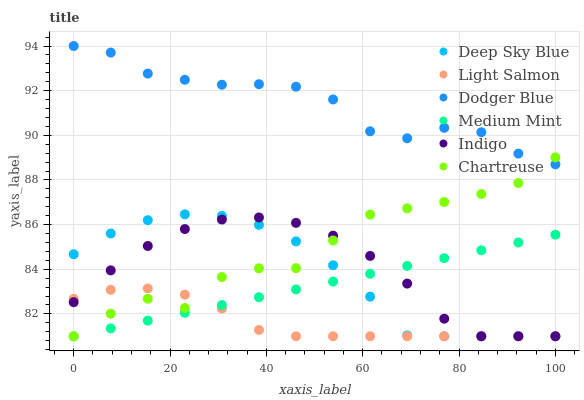Does Light Salmon have the minimum area under the curve?
Answer yes or no. Yes. Does Dodger Blue have the maximum area under the curve?
Answer yes or no. Yes. Does Indigo have the minimum area under the curve?
Answer yes or no. No. Does Indigo have the maximum area under the curve?
Answer yes or no. No. Is Medium Mint the smoothest?
Answer yes or no. Yes. Is Chartreuse the roughest?
Answer yes or no. Yes. Is Light Salmon the smoothest?
Answer yes or no. No. Is Light Salmon the roughest?
Answer yes or no. No. Does Medium Mint have the lowest value?
Answer yes or no. Yes. Does Dodger Blue have the lowest value?
Answer yes or no. No. Does Dodger Blue have the highest value?
Answer yes or no. Yes. Does Indigo have the highest value?
Answer yes or no. No. Is Medium Mint less than Dodger Blue?
Answer yes or no. Yes. Is Dodger Blue greater than Light Salmon?
Answer yes or no. Yes. Does Chartreuse intersect Deep Sky Blue?
Answer yes or no. Yes. Is Chartreuse less than Deep Sky Blue?
Answer yes or no. No. Is Chartreuse greater than Deep Sky Blue?
Answer yes or no. No. Does Medium Mint intersect Dodger Blue?
Answer yes or no. No. 